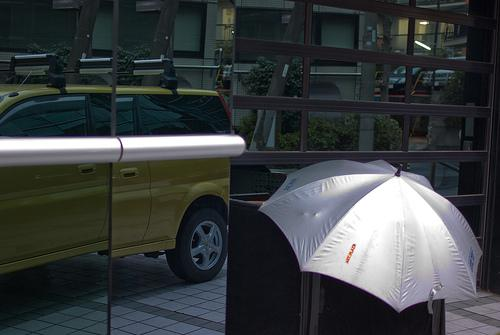Question: what color is the umbrella?
Choices:
A. Teal.
B. Purple.
C. Silver.
D. Neon.
Answer with the letter. Answer: C Question: how many tall trees do you count in the background?
Choices:
A. Five.
B. Six.
C. Four.
D. Ten.
Answer with the letter. Answer: C 